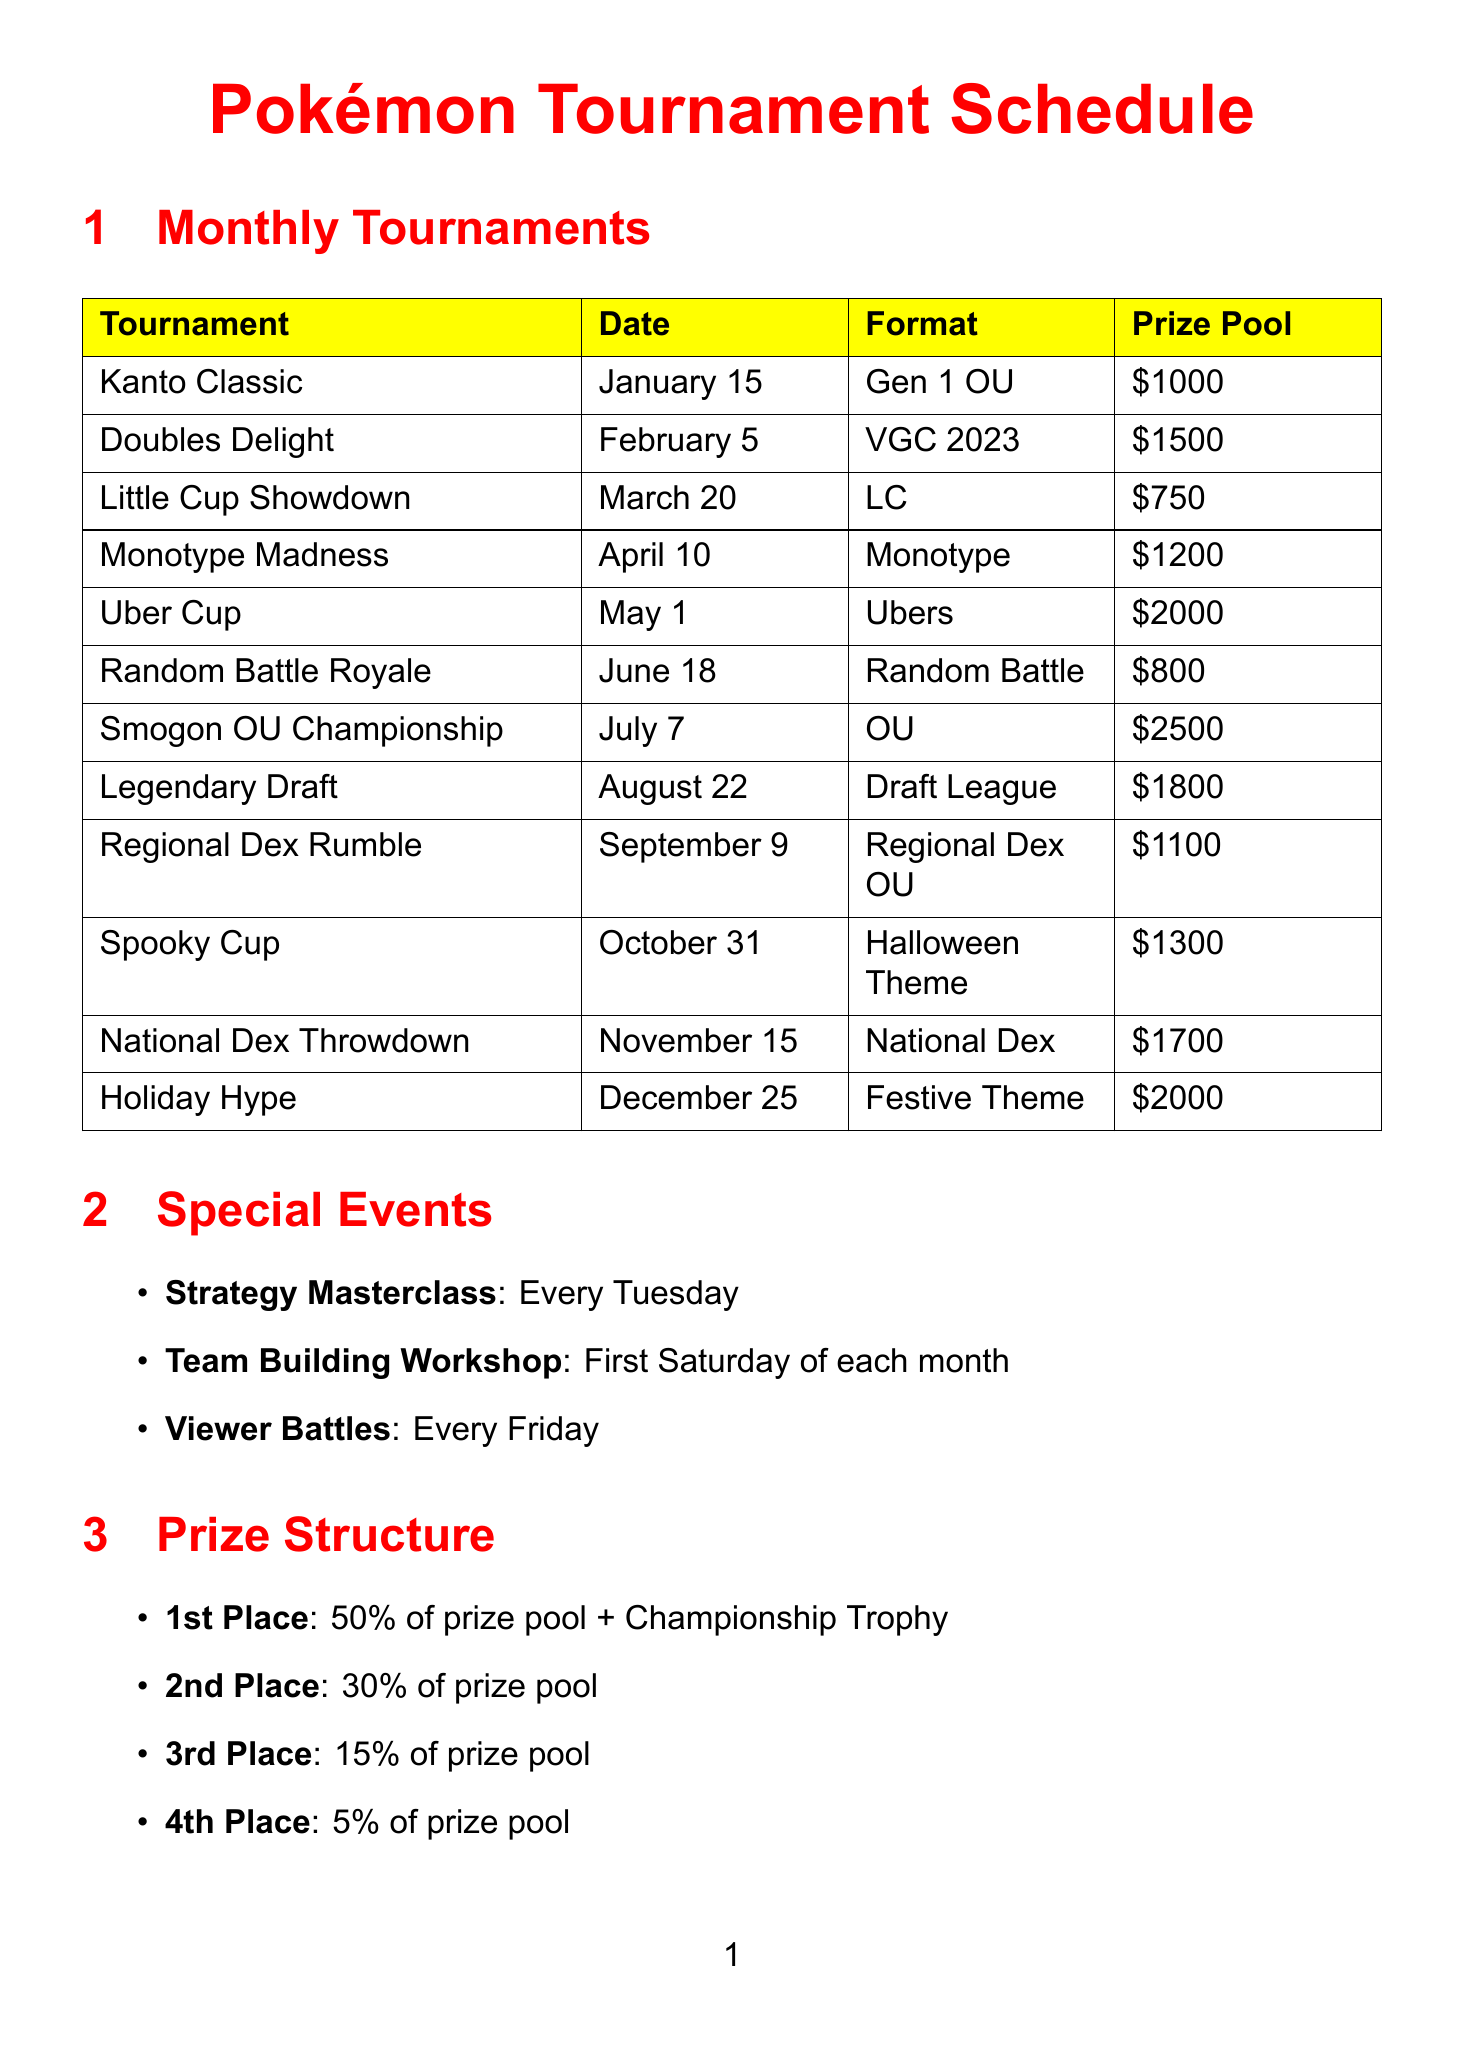What is the prize pool for the Smogon OU Championship? The prize pool for the Smogon OU Championship is listed in the document as $2500.
Answer: $2500 When is the Little Cup Showdown scheduled? The document specifies that the Little Cup Showdown is on March 20.
Answer: March 20 What format is used in the Uber Cup? The Uber Cup format is mentioned as Ubers in the document.
Answer: Ubers How much is the entry fee for tournaments? The entry fee for tournaments is given as $5 or 500 channel points.
Answer: $5 or 500 channel points On which day are viewer battles held? Viewer battles are mentioned to occur every Friday according to the document.
Answer: Friday Which tournament has the highest prize pool? The document indicates that the tournament with the highest prize pool is the Smogon OU Championship with $2500.
Answer: Smogon OU Championship What theme is the Spooky Cup based on? The Spooky Cup theme is based on Halloween as specified in the document.
Answer: Halloween Theme How many tournaments are listed in the monthly tournament schedule? The document counts a total of 12 tournaments listed in the monthly tournament schedule.
Answer: 12 What is the maximum number of participants allowed in the tournaments? The document states that the maximum number of participants allowed is 128.
Answer: 128 When do live streams start according to the streaming schedule? The streaming schedule indicates that live streams start at 7:00 PM EST.
Answer: 7:00 PM EST 